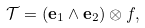<formula> <loc_0><loc_0><loc_500><loc_500>\mathcal { T } = ( \mathbf e _ { 1 } \wedge \mathbf e _ { 2 } ) \otimes f ,</formula> 